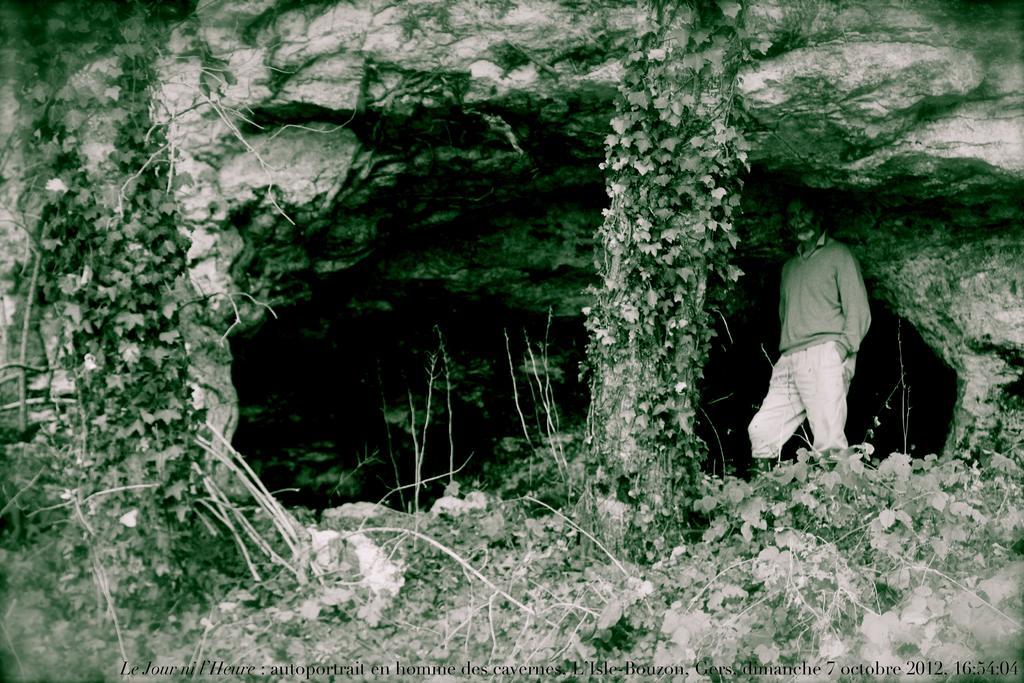Please provide a concise description of this image. In this image we can see person, trees, plants and cave. 